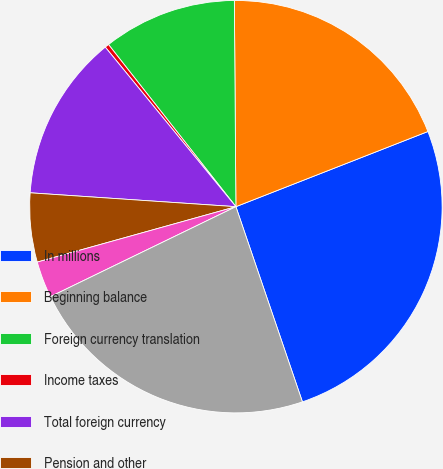Convert chart to OTSL. <chart><loc_0><loc_0><loc_500><loc_500><pie_chart><fcel>In millions<fcel>Beginning balance<fcel>Foreign currency translation<fcel>Income taxes<fcel>Total foreign currency<fcel>Pension and other<fcel>Total pension and other<fcel>Ending balance<nl><fcel>25.71%<fcel>19.18%<fcel>10.48%<fcel>0.32%<fcel>13.01%<fcel>5.4%<fcel>2.86%<fcel>23.04%<nl></chart> 